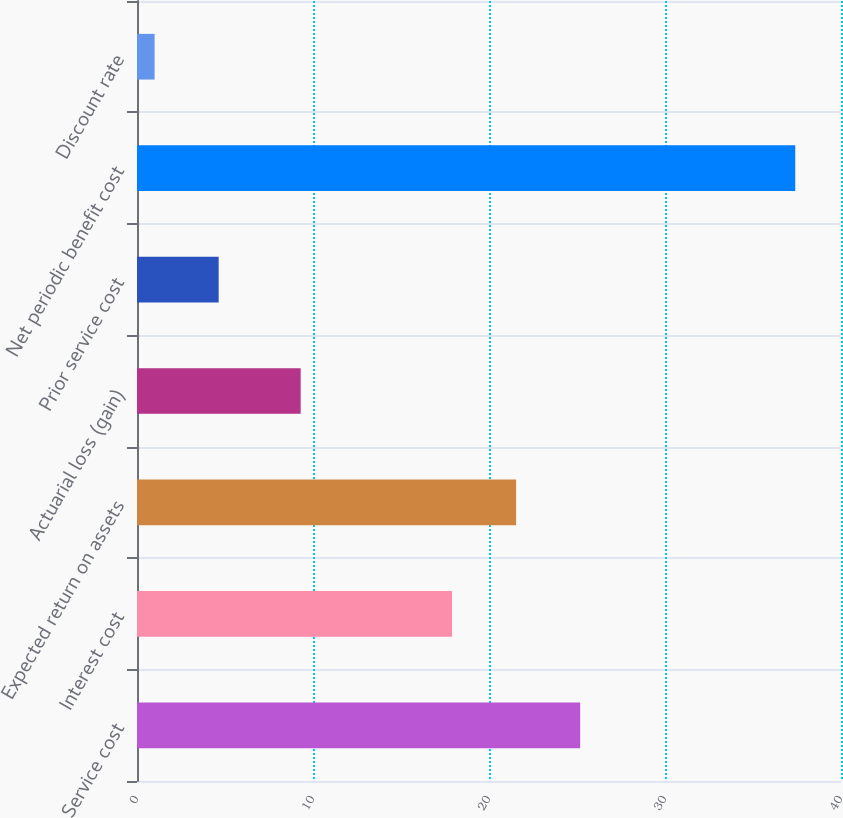Convert chart. <chart><loc_0><loc_0><loc_500><loc_500><bar_chart><fcel>Service cost<fcel>Interest cost<fcel>Expected return on assets<fcel>Actuarial loss (gain)<fcel>Prior service cost<fcel>Net periodic benefit cost<fcel>Discount rate<nl><fcel>25.18<fcel>17.9<fcel>21.54<fcel>9.3<fcel>4.64<fcel>37.4<fcel>1<nl></chart> 